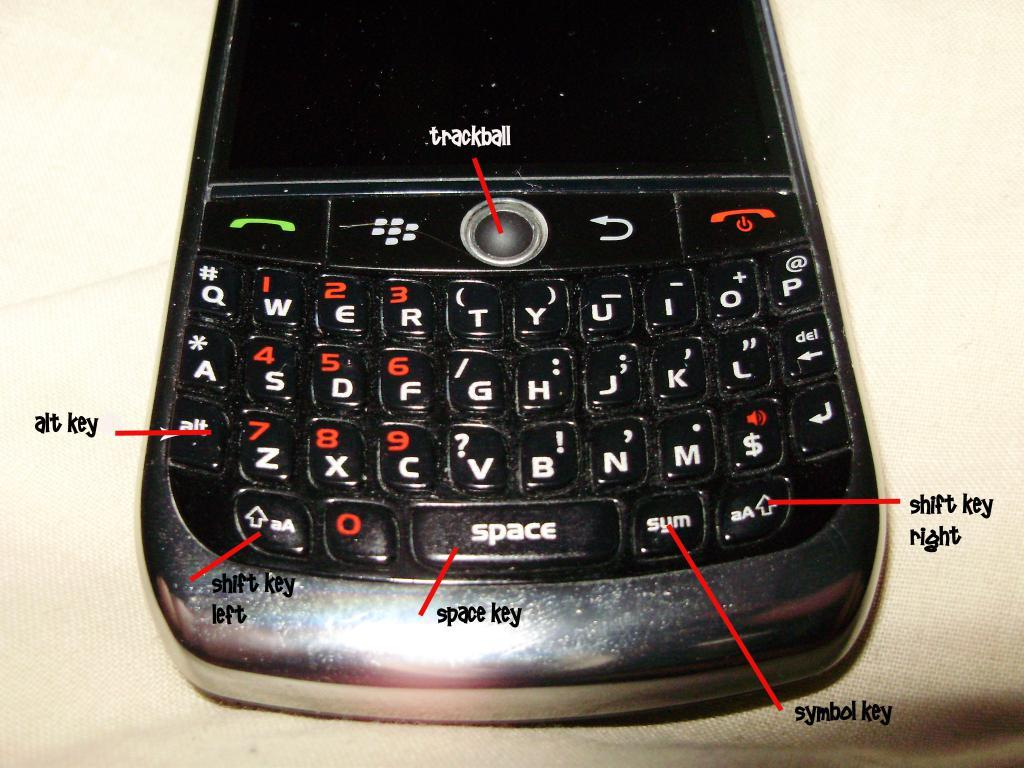<image>
Relay a brief, clear account of the picture shown. I diagram of the keys on a Blackberry phone that include things like the alt and space key 